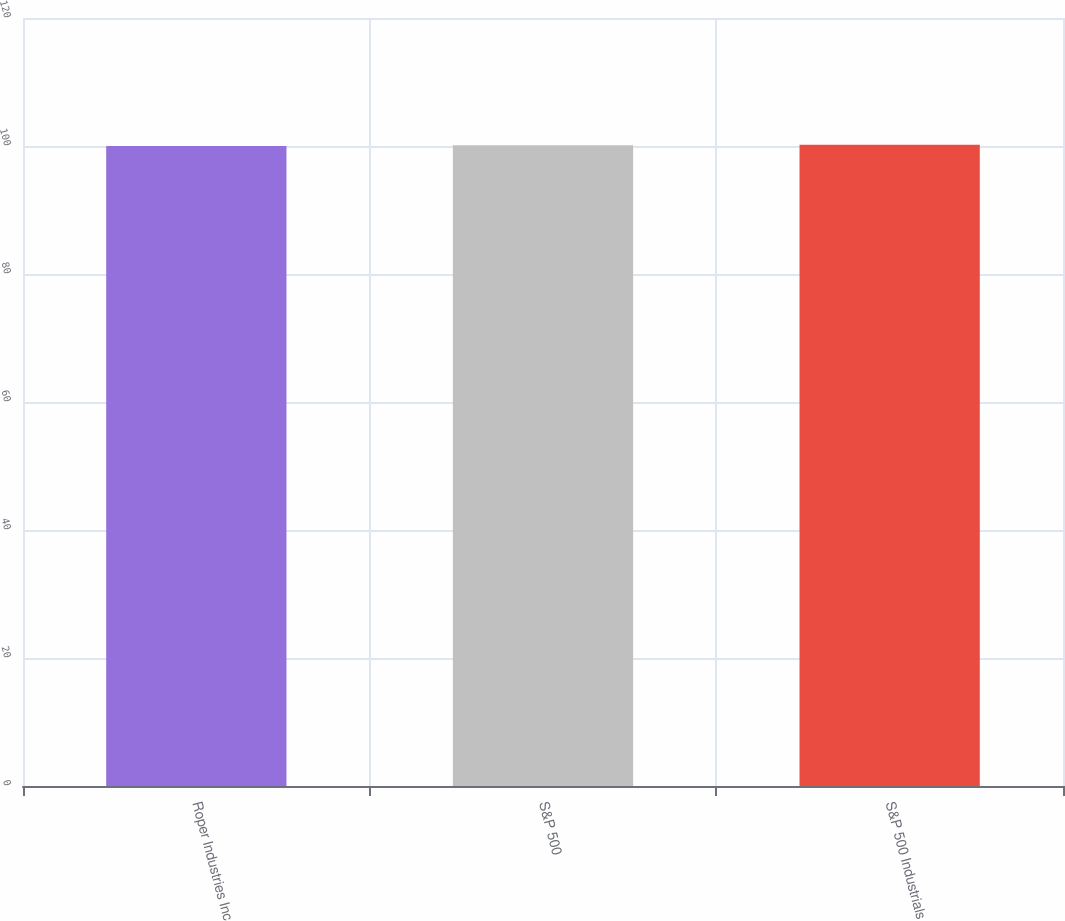<chart> <loc_0><loc_0><loc_500><loc_500><bar_chart><fcel>Roper Industries Inc<fcel>S&P 500<fcel>S&P 500 Industrials<nl><fcel>100<fcel>100.1<fcel>100.2<nl></chart> 